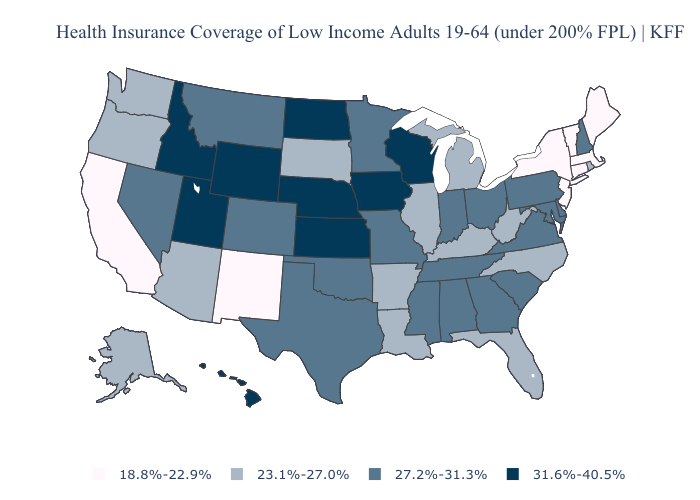Name the states that have a value in the range 31.6%-40.5%?
Keep it brief. Hawaii, Idaho, Iowa, Kansas, Nebraska, North Dakota, Utah, Wisconsin, Wyoming. Name the states that have a value in the range 31.6%-40.5%?
Write a very short answer. Hawaii, Idaho, Iowa, Kansas, Nebraska, North Dakota, Utah, Wisconsin, Wyoming. Name the states that have a value in the range 23.1%-27.0%?
Answer briefly. Alaska, Arizona, Arkansas, Florida, Illinois, Kentucky, Louisiana, Michigan, North Carolina, Oregon, Rhode Island, South Dakota, Washington, West Virginia. Name the states that have a value in the range 18.8%-22.9%?
Quick response, please. California, Connecticut, Maine, Massachusetts, New Jersey, New Mexico, New York, Vermont. What is the value of Pennsylvania?
Keep it brief. 27.2%-31.3%. Does Kansas have a higher value than Maryland?
Short answer required. Yes. Name the states that have a value in the range 27.2%-31.3%?
Give a very brief answer. Alabama, Colorado, Delaware, Georgia, Indiana, Maryland, Minnesota, Mississippi, Missouri, Montana, Nevada, New Hampshire, Ohio, Oklahoma, Pennsylvania, South Carolina, Tennessee, Texas, Virginia. Among the states that border South Carolina , which have the highest value?
Quick response, please. Georgia. What is the value of Iowa?
Keep it brief. 31.6%-40.5%. Does Arizona have a lower value than Illinois?
Write a very short answer. No. Name the states that have a value in the range 27.2%-31.3%?
Be succinct. Alabama, Colorado, Delaware, Georgia, Indiana, Maryland, Minnesota, Mississippi, Missouri, Montana, Nevada, New Hampshire, Ohio, Oklahoma, Pennsylvania, South Carolina, Tennessee, Texas, Virginia. What is the value of Iowa?
Answer briefly. 31.6%-40.5%. Does North Carolina have the highest value in the South?
Write a very short answer. No. Name the states that have a value in the range 27.2%-31.3%?
Answer briefly. Alabama, Colorado, Delaware, Georgia, Indiana, Maryland, Minnesota, Mississippi, Missouri, Montana, Nevada, New Hampshire, Ohio, Oklahoma, Pennsylvania, South Carolina, Tennessee, Texas, Virginia. Does Missouri have the highest value in the MidWest?
Answer briefly. No. 